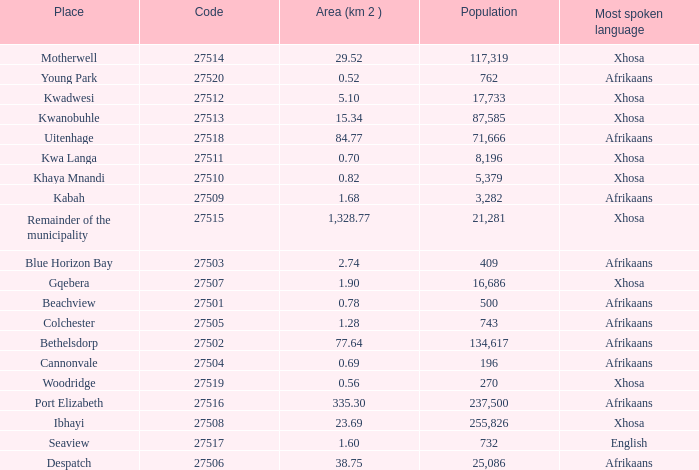Can you parse all the data within this table? {'header': ['Place', 'Code', 'Area (km 2 )', 'Population', 'Most spoken language'], 'rows': [['Motherwell', '27514', '29.52', '117,319', 'Xhosa'], ['Young Park', '27520', '0.52', '762', 'Afrikaans'], ['Kwadwesi', '27512', '5.10', '17,733', 'Xhosa'], ['Kwanobuhle', '27513', '15.34', '87,585', 'Xhosa'], ['Uitenhage', '27518', '84.77', '71,666', 'Afrikaans'], ['Kwa Langa', '27511', '0.70', '8,196', 'Xhosa'], ['Khaya Mnandi', '27510', '0.82', '5,379', 'Xhosa'], ['Kabah', '27509', '1.68', '3,282', 'Afrikaans'], ['Remainder of the municipality', '27515', '1,328.77', '21,281', 'Xhosa'], ['Blue Horizon Bay', '27503', '2.74', '409', 'Afrikaans'], ['Gqebera', '27507', '1.90', '16,686', 'Xhosa'], ['Beachview', '27501', '0.78', '500', 'Afrikaans'], ['Colchester', '27505', '1.28', '743', 'Afrikaans'], ['Bethelsdorp', '27502', '77.64', '134,617', 'Afrikaans'], ['Cannonvale', '27504', '0.69', '196', 'Afrikaans'], ['Woodridge', '27519', '0.56', '270', 'Xhosa'], ['Port Elizabeth', '27516', '335.30', '237,500', 'Afrikaans'], ['Ibhayi', '27508', '23.69', '255,826', 'Xhosa'], ['Seaview', '27517', '1.60', '732', 'English'], ['Despatch', '27506', '38.75', '25,086', 'Afrikaans']]} What is the lowest code number for the remainder of the municipality that has an area bigger than 15.34 squared kilometers, a population greater than 762 and a language of xhosa spoken? 27515.0. 